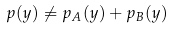Convert formula to latex. <formula><loc_0><loc_0><loc_500><loc_500>p ( y ) \not = p _ { A } ( y ) + p _ { B } ( y ) \</formula> 